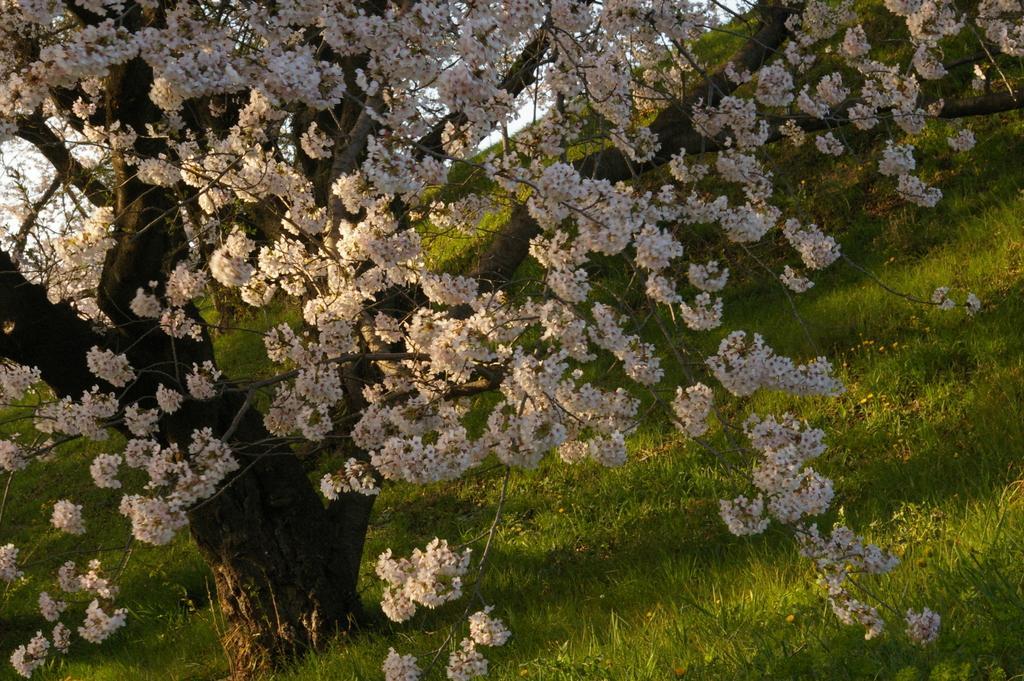How would you summarize this image in a sentence or two? In the image there is flower tree on the grassland and at the back its sky. 